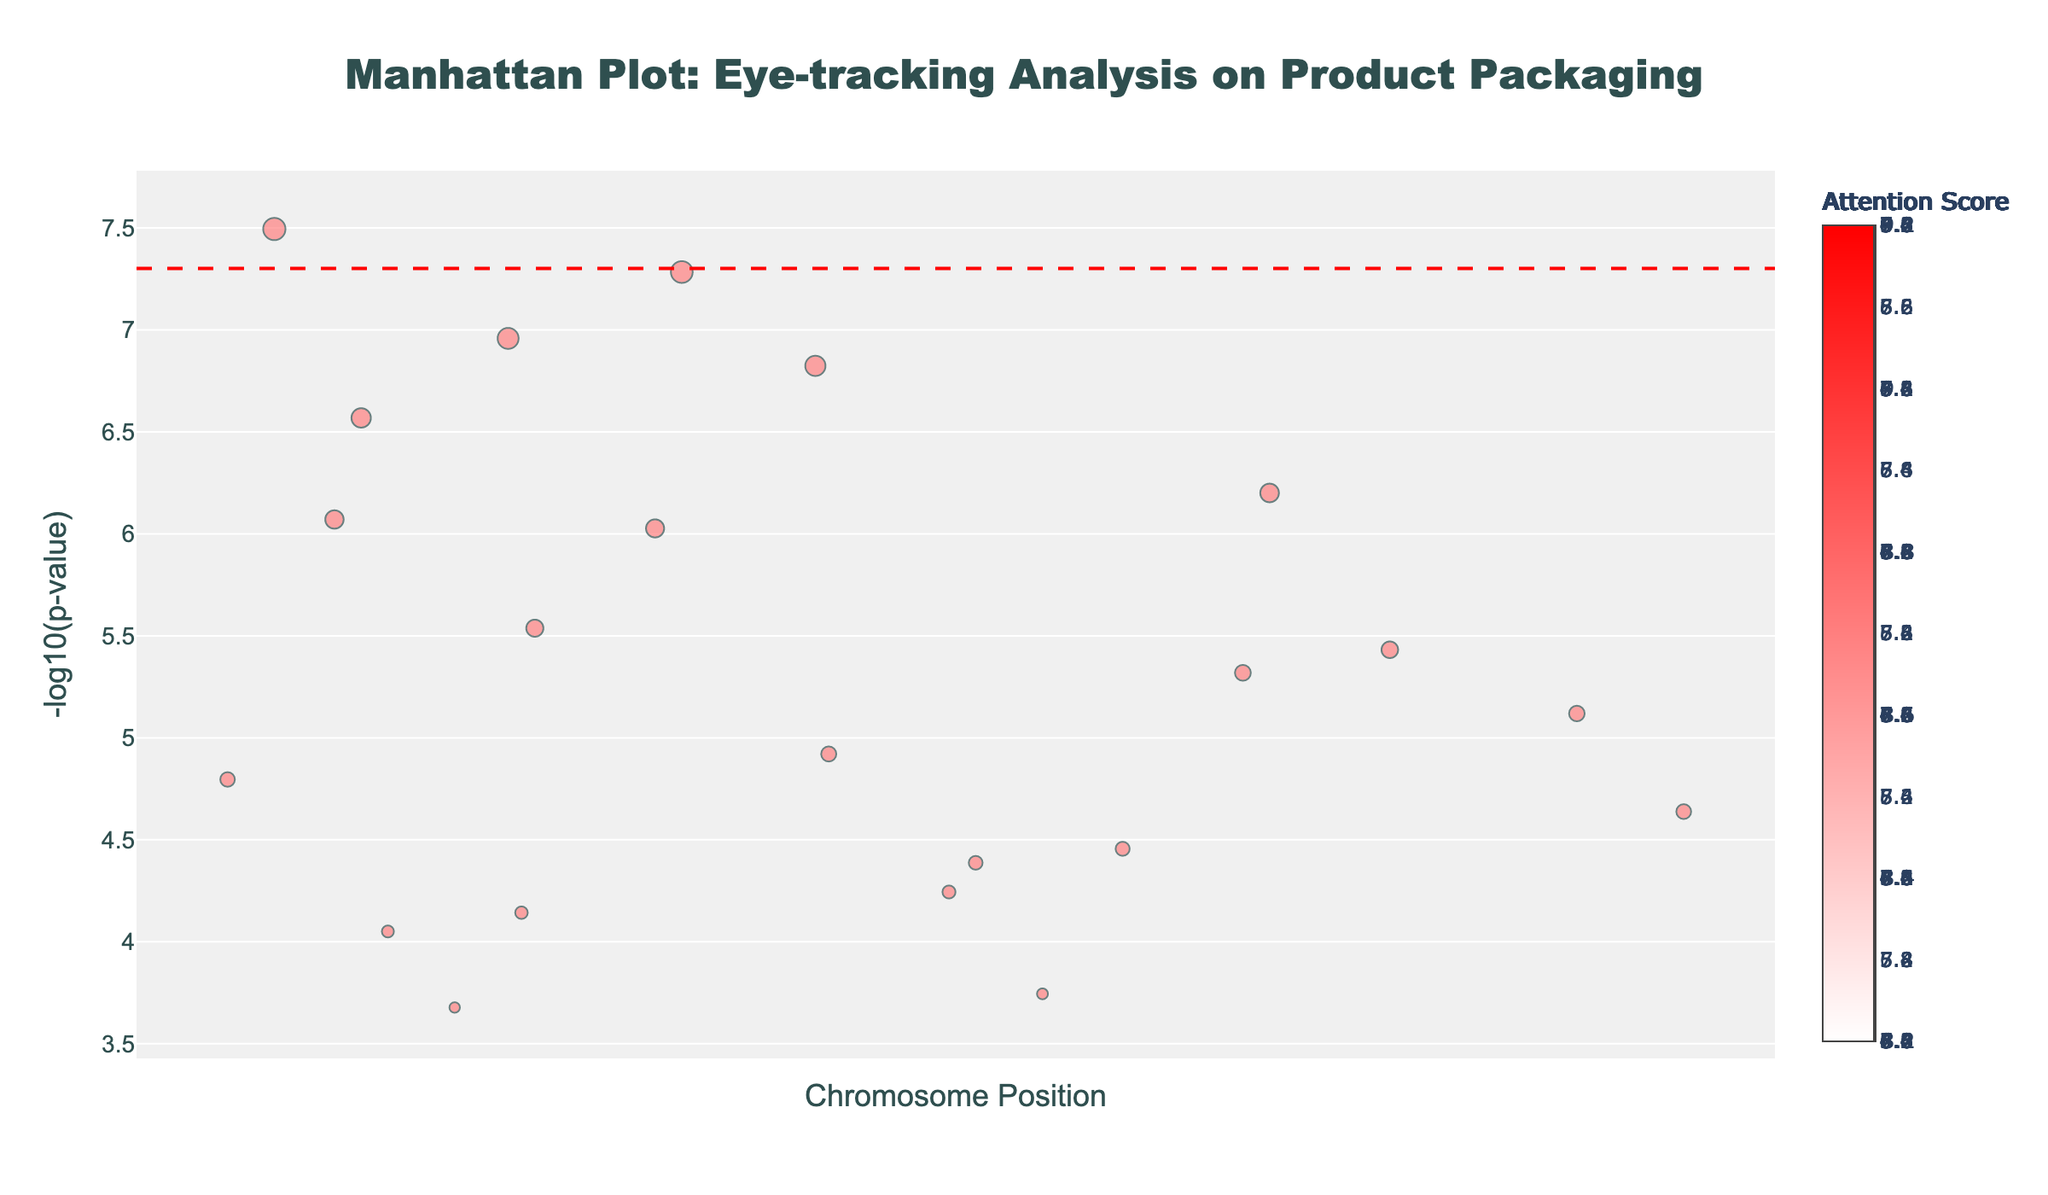What is the title of the plot? The plot title is prominently displayed at the top center of the figure. This information can be directly read from the top of the graph.
Answer: Manhattan Plot: Eye-tracking Analysis on Product Packaging What does the y-axis represent? The y-axis label can be read from the left side of the plot. It is labeled as "-log10(p-value)" which indicates that the y-axis represents the negative logarithm of the p-value.
Answer: -log10(p-value) What is the significance threshold in this plot? The significance threshold is marked by a dashed red line across the plot. The value can be derived from the y-axis where the line intersects. The threshold is set at -log10(5e-8).
Answer: -log10(5e-8) Which product element has the highest attention score? By hovering over the data points, we can see that the "Logo" at position 14500000 on Chromosome 1 has the highest attention score of 8.7.
Answer: Logo How many product elements have attention scores greater than 7.0? By examining the color intensity of the markers and checking the hover data, we can count the product elements with attention scores greater than 7.0. These include Logo, Product_Name, Brand_Colors, Product_Image, Quality_Seal, Promotional_Offer, and Organic_Certification, totaling 7 elements.
Answer: 7 Which chromosome has the product element with the smallest negative log p-value? By looking for the point with the lowest y-axis value and checking its chromosome, we see that the element "Social_Media_Links" on Chromosome 22 has the smallest negative log p-value, represented by a high p-value of 2.1e-4.
Answer: Chromosome 22 What is the product element found at position 112000000 on Chromosome 11? By referencing the chromosome and position on the x-axis, and then using the hover data, we find that the product element at this position is "Serving_Size".
Answer: Serving_Size Which product element is at position 33000000 on Chromosome 20 and what is its attention score? By checking the chromosome and position using the x-axis, and referring to the hover text, we find that the element is "QR_Code" with an attention score of 4.9.
Answer: QR_Code, 4.9 What is the combined attention score of elements on Chromosome 3 and Chromosome 7? Adding the attention scores of "Nutrition_Label" on Chromosome 3 (6.2) and "Product_Image" on Chromosome 7 (8.5) results in a combined score of 14.7.
Answer: 14.7 